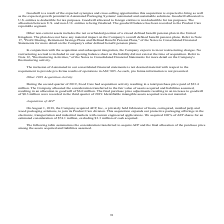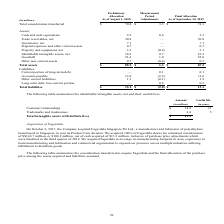According to Sealed Air Corporation's financial document, What company was acquired in 2018? According to the financial document, AFP, Inc.. The relevant text states: "On August 1, 2018, the Company acquired AFP, Inc., a privately held fabricator of foam, corrugated, molded pulp and wood packaging solutions, to join..." Also, What does this table show? The following table summarizes the consideration transferred to acquire AFP and the final allocation of the purchase price among the assets acquired and liabilities assumed.. The document states: "The following table summarizes the consideration transferred to acquire AFP and the final allocation of the purchase price among the assets acquired a..." Also, What is the adjustment in assets between August 1, 2018 and September 30, 2019? According to the financial document, $ 3.3 (in millions). The relevant text states: "er 30, 2019 Total consideration transferred $ 70.8 $ 3.3 $ 74.1..." Also, can you calculate: What is the liability to asset ratio as of August 1, 2018? Based on the calculation: 15.1/85.9, the result is 17.58 (percentage). This is based on the information: "Total liabilities $ 15.1 $ (2.0) $ 13.1 Total assets $ 85.9 $ 1.3 $ 87.2..." The key data points involved are: 15.1, 85.9. Also, can you calculate: What is the difference between the liability to asset ratio from As of August 1, 2018 to As of September 30, 2019? To answer this question, I need to perform calculations using the financial data. The calculation is: (15.1/85.9)-(13.1/87.2), which equals 2.56 (percentage). This is based on the information: "Total assets $ 85.9 $ 1.3 $ 87.2 Total liabilities $ 15.1 $ (2.0) $ 13.1 Total liabilities $ 15.1 $ (2.0) $ 13.1 Total assets $ 85.9 $ 1.3 $ 87.2..." The key data points involved are: 13.1, 15.1, 85.9. Also, can you calculate: What is the adjustment of total liabilities expressed as a percentage of total liabilities as of August 1, 2018? To answer this question, I need to perform calculations using the financial data. The calculation is: -2.0/15.1, which equals -13.25 (percentage). This is based on the information: "Total liabilities $ 15.1 $ (2.0) $ 13.1 Total liabilities $ 15.1 $ (2.0) $ 13.1..." The key data points involved are: 15.1, 2.0. 